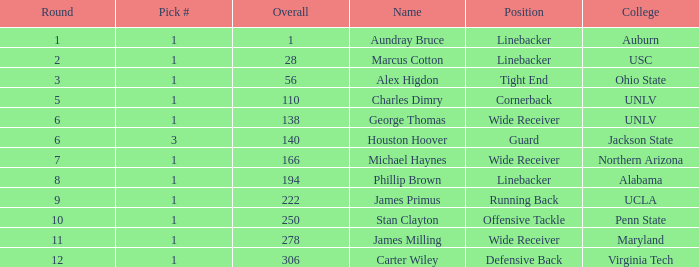In which round was george thomas selected? 6.0. 